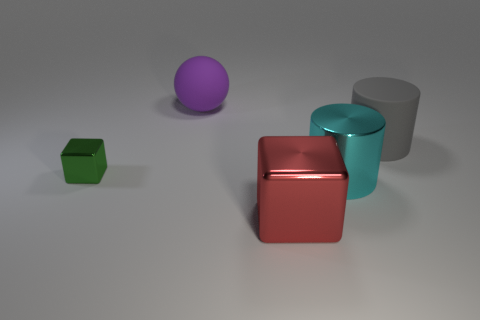Add 3 yellow rubber objects. How many objects exist? 8 Subtract all balls. How many objects are left? 4 Subtract all large blue cylinders. Subtract all red metal blocks. How many objects are left? 4 Add 3 shiny cubes. How many shiny cubes are left? 5 Add 2 matte cylinders. How many matte cylinders exist? 3 Subtract 0 cyan balls. How many objects are left? 5 